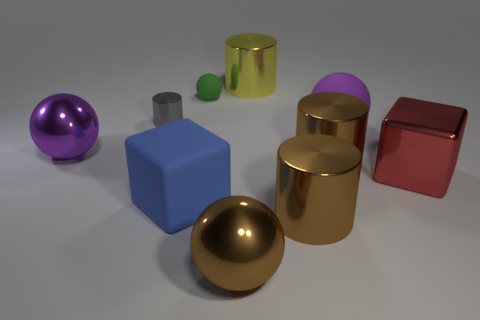Subtract all gray cylinders. How many cylinders are left? 3 Subtract all tiny gray cylinders. How many cylinders are left? 3 Subtract all red cylinders. Subtract all blue spheres. How many cylinders are left? 4 Subtract all spheres. How many objects are left? 6 Add 8 blue rubber blocks. How many blue rubber blocks are left? 9 Add 1 gray shiny cylinders. How many gray shiny cylinders exist? 2 Subtract 0 red cylinders. How many objects are left? 10 Subtract all large rubber objects. Subtract all purple things. How many objects are left? 6 